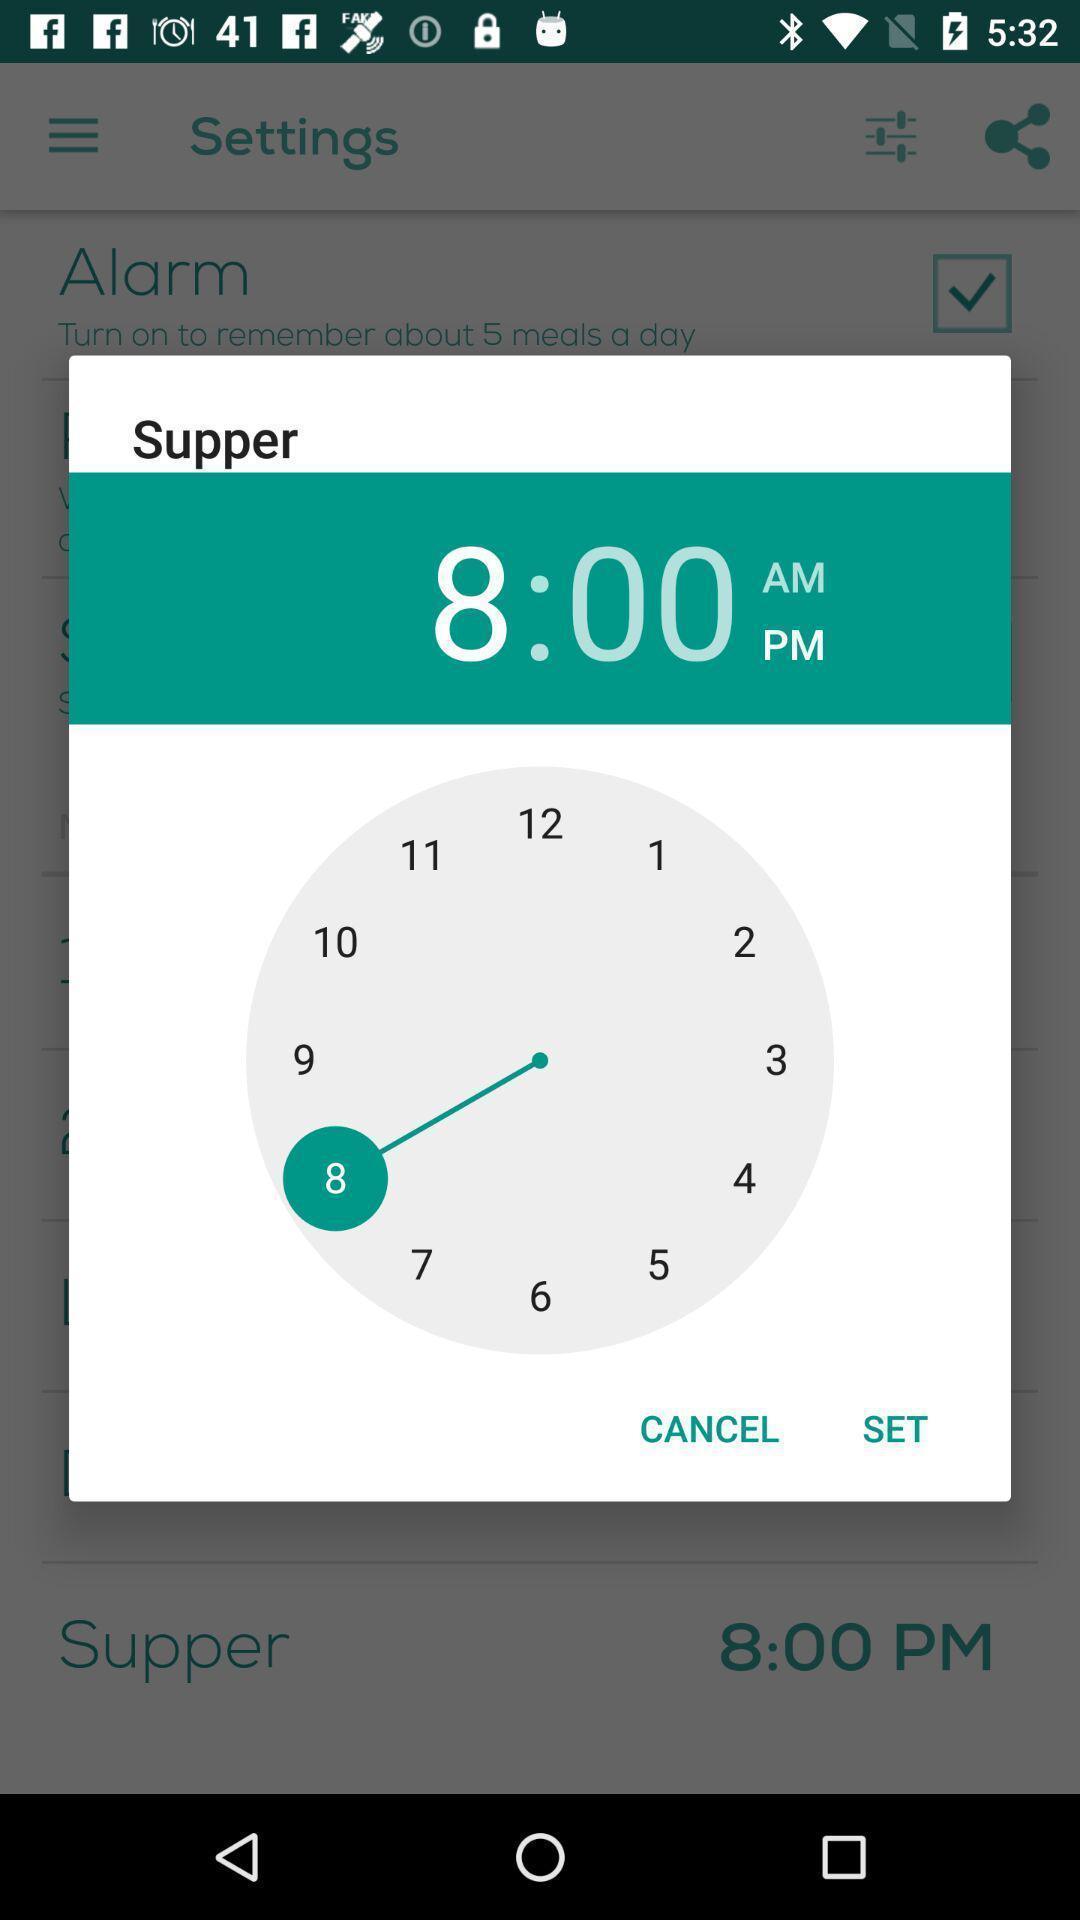What can you discern from this picture? Setting an alarm for meals. 